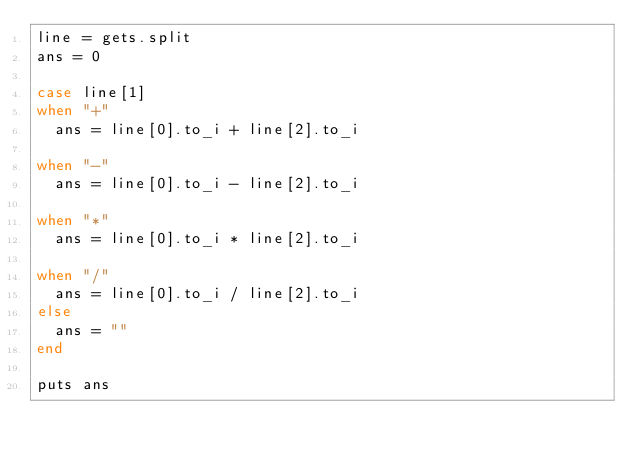Convert code to text. <code><loc_0><loc_0><loc_500><loc_500><_Ruby_>line = gets.split
ans = 0

case line[1]
when "+"
  ans = line[0].to_i + line[2].to_i

when "-"
  ans = line[0].to_i - line[2].to_i

when "*"
  ans = line[0].to_i * line[2].to_i

when "/"
  ans = line[0].to_i / line[2].to_i
else
  ans = ""
end

puts ans
</code> 